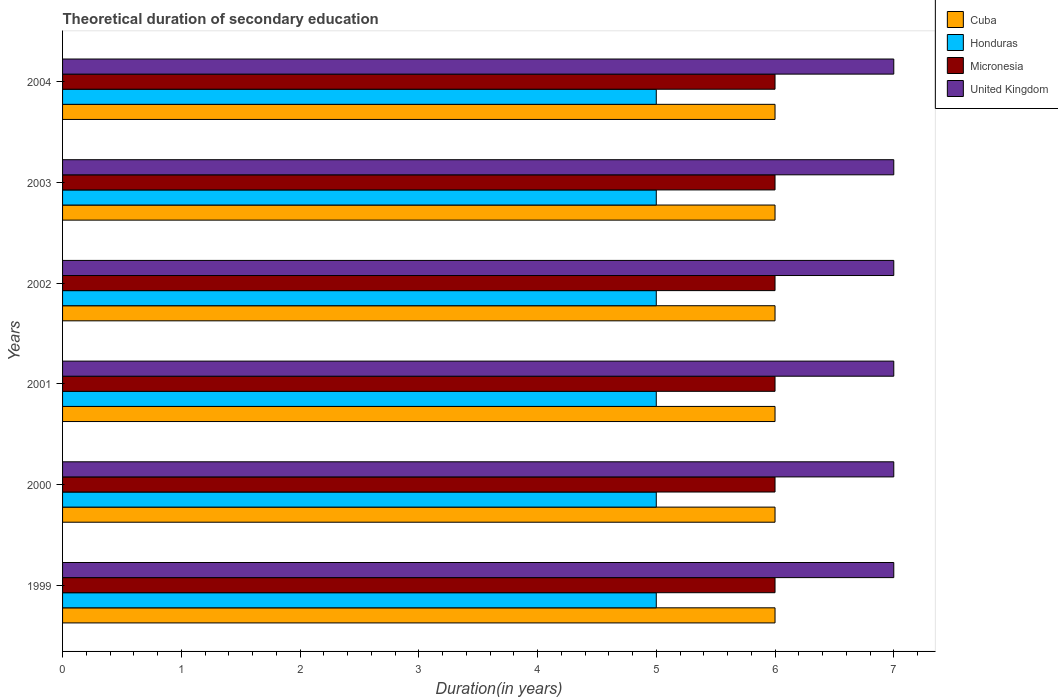How many different coloured bars are there?
Your response must be concise. 4. Are the number of bars per tick equal to the number of legend labels?
Your answer should be compact. Yes. Are the number of bars on each tick of the Y-axis equal?
Keep it short and to the point. Yes. How many bars are there on the 2nd tick from the top?
Offer a terse response. 4. How many bars are there on the 6th tick from the bottom?
Offer a terse response. 4. What is the total theoretical duration of secondary education in United Kingdom in 2004?
Ensure brevity in your answer.  7. Across all years, what is the maximum total theoretical duration of secondary education in Cuba?
Your response must be concise. 6. Across all years, what is the minimum total theoretical duration of secondary education in United Kingdom?
Make the answer very short. 7. In which year was the total theoretical duration of secondary education in Honduras maximum?
Provide a succinct answer. 1999. In which year was the total theoretical duration of secondary education in Cuba minimum?
Your response must be concise. 1999. What is the total total theoretical duration of secondary education in Honduras in the graph?
Keep it short and to the point. 30. What is the difference between the total theoretical duration of secondary education in United Kingdom in 2000 and the total theoretical duration of secondary education in Honduras in 2001?
Offer a very short reply. 2. In the year 1999, what is the difference between the total theoretical duration of secondary education in United Kingdom and total theoretical duration of secondary education in Honduras?
Keep it short and to the point. 2. What is the difference between the highest and the lowest total theoretical duration of secondary education in United Kingdom?
Make the answer very short. 0. In how many years, is the total theoretical duration of secondary education in Honduras greater than the average total theoretical duration of secondary education in Honduras taken over all years?
Offer a very short reply. 0. Is the sum of the total theoretical duration of secondary education in Cuba in 2001 and 2004 greater than the maximum total theoretical duration of secondary education in United Kingdom across all years?
Make the answer very short. Yes. Is it the case that in every year, the sum of the total theoretical duration of secondary education in Cuba and total theoretical duration of secondary education in Honduras is greater than the sum of total theoretical duration of secondary education in Micronesia and total theoretical duration of secondary education in United Kingdom?
Your response must be concise. Yes. What does the 1st bar from the top in 2002 represents?
Offer a terse response. United Kingdom. What does the 3rd bar from the bottom in 2002 represents?
Offer a very short reply. Micronesia. Are all the bars in the graph horizontal?
Provide a succinct answer. Yes. How many years are there in the graph?
Ensure brevity in your answer.  6. Are the values on the major ticks of X-axis written in scientific E-notation?
Your response must be concise. No. Does the graph contain any zero values?
Keep it short and to the point. No. Where does the legend appear in the graph?
Your answer should be compact. Top right. How many legend labels are there?
Ensure brevity in your answer.  4. How are the legend labels stacked?
Your response must be concise. Vertical. What is the title of the graph?
Your answer should be compact. Theoretical duration of secondary education. What is the label or title of the X-axis?
Provide a short and direct response. Duration(in years). What is the label or title of the Y-axis?
Provide a short and direct response. Years. What is the Duration(in years) in Cuba in 1999?
Ensure brevity in your answer.  6. What is the Duration(in years) of Honduras in 1999?
Make the answer very short. 5. What is the Duration(in years) in Micronesia in 1999?
Your response must be concise. 6. What is the Duration(in years) in United Kingdom in 1999?
Your response must be concise. 7. What is the Duration(in years) of Cuba in 2000?
Provide a succinct answer. 6. What is the Duration(in years) in Honduras in 2000?
Keep it short and to the point. 5. What is the Duration(in years) of Micronesia in 2000?
Offer a terse response. 6. What is the Duration(in years) of Cuba in 2001?
Provide a short and direct response. 6. What is the Duration(in years) of Cuba in 2002?
Your answer should be very brief. 6. What is the Duration(in years) of Honduras in 2002?
Keep it short and to the point. 5. What is the Duration(in years) in Micronesia in 2003?
Keep it short and to the point. 6. What is the Duration(in years) of Honduras in 2004?
Offer a terse response. 5. What is the Duration(in years) in Micronesia in 2004?
Make the answer very short. 6. What is the Duration(in years) in United Kingdom in 2004?
Provide a short and direct response. 7. Across all years, what is the maximum Duration(in years) of Honduras?
Ensure brevity in your answer.  5. Across all years, what is the minimum Duration(in years) in United Kingdom?
Provide a succinct answer. 7. What is the total Duration(in years) in Micronesia in the graph?
Provide a succinct answer. 36. What is the difference between the Duration(in years) of Cuba in 1999 and that in 2000?
Ensure brevity in your answer.  0. What is the difference between the Duration(in years) in Honduras in 1999 and that in 2000?
Give a very brief answer. 0. What is the difference between the Duration(in years) of Micronesia in 1999 and that in 2000?
Your response must be concise. 0. What is the difference between the Duration(in years) of United Kingdom in 1999 and that in 2001?
Provide a succinct answer. 0. What is the difference between the Duration(in years) of Cuba in 1999 and that in 2002?
Make the answer very short. 0. What is the difference between the Duration(in years) of Honduras in 1999 and that in 2002?
Make the answer very short. 0. What is the difference between the Duration(in years) in United Kingdom in 1999 and that in 2002?
Make the answer very short. 0. What is the difference between the Duration(in years) of Cuba in 1999 and that in 2003?
Your answer should be very brief. 0. What is the difference between the Duration(in years) in Honduras in 1999 and that in 2004?
Your answer should be very brief. 0. What is the difference between the Duration(in years) of Micronesia in 1999 and that in 2004?
Your answer should be compact. 0. What is the difference between the Duration(in years) of Honduras in 2000 and that in 2002?
Offer a terse response. 0. What is the difference between the Duration(in years) of United Kingdom in 2000 and that in 2002?
Your response must be concise. 0. What is the difference between the Duration(in years) in Cuba in 2000 and that in 2003?
Provide a succinct answer. 0. What is the difference between the Duration(in years) of United Kingdom in 2000 and that in 2003?
Provide a short and direct response. 0. What is the difference between the Duration(in years) in Cuba in 2001 and that in 2002?
Offer a very short reply. 0. What is the difference between the Duration(in years) in United Kingdom in 2001 and that in 2002?
Offer a terse response. 0. What is the difference between the Duration(in years) of Cuba in 2001 and that in 2003?
Provide a short and direct response. 0. What is the difference between the Duration(in years) of Honduras in 2001 and that in 2003?
Keep it short and to the point. 0. What is the difference between the Duration(in years) in Cuba in 2002 and that in 2003?
Offer a very short reply. 0. What is the difference between the Duration(in years) of Honduras in 2002 and that in 2003?
Ensure brevity in your answer.  0. What is the difference between the Duration(in years) of Micronesia in 2002 and that in 2003?
Offer a very short reply. 0. What is the difference between the Duration(in years) in United Kingdom in 2002 and that in 2003?
Ensure brevity in your answer.  0. What is the difference between the Duration(in years) in Micronesia in 2003 and that in 2004?
Provide a short and direct response. 0. What is the difference between the Duration(in years) of United Kingdom in 2003 and that in 2004?
Provide a short and direct response. 0. What is the difference between the Duration(in years) of Honduras in 1999 and the Duration(in years) of United Kingdom in 2000?
Your answer should be compact. -2. What is the difference between the Duration(in years) of Honduras in 1999 and the Duration(in years) of Micronesia in 2001?
Offer a terse response. -1. What is the difference between the Duration(in years) in Honduras in 1999 and the Duration(in years) in United Kingdom in 2001?
Ensure brevity in your answer.  -2. What is the difference between the Duration(in years) in Cuba in 1999 and the Duration(in years) in Honduras in 2002?
Give a very brief answer. 1. What is the difference between the Duration(in years) of Cuba in 1999 and the Duration(in years) of United Kingdom in 2002?
Your answer should be very brief. -1. What is the difference between the Duration(in years) in Honduras in 1999 and the Duration(in years) in Micronesia in 2002?
Your response must be concise. -1. What is the difference between the Duration(in years) in Cuba in 1999 and the Duration(in years) in Micronesia in 2003?
Give a very brief answer. 0. What is the difference between the Duration(in years) of Cuba in 1999 and the Duration(in years) of United Kingdom in 2003?
Your answer should be compact. -1. What is the difference between the Duration(in years) of Honduras in 1999 and the Duration(in years) of Micronesia in 2003?
Provide a succinct answer. -1. What is the difference between the Duration(in years) in Micronesia in 1999 and the Duration(in years) in United Kingdom in 2003?
Offer a very short reply. -1. What is the difference between the Duration(in years) of Cuba in 1999 and the Duration(in years) of Honduras in 2004?
Ensure brevity in your answer.  1. What is the difference between the Duration(in years) of Honduras in 1999 and the Duration(in years) of United Kingdom in 2004?
Offer a terse response. -2. What is the difference between the Duration(in years) of Micronesia in 1999 and the Duration(in years) of United Kingdom in 2004?
Make the answer very short. -1. What is the difference between the Duration(in years) of Cuba in 2000 and the Duration(in years) of United Kingdom in 2001?
Your answer should be compact. -1. What is the difference between the Duration(in years) of Micronesia in 2000 and the Duration(in years) of United Kingdom in 2001?
Your answer should be compact. -1. What is the difference between the Duration(in years) in Cuba in 2000 and the Duration(in years) in Honduras in 2002?
Provide a short and direct response. 1. What is the difference between the Duration(in years) in Honduras in 2000 and the Duration(in years) in Micronesia in 2002?
Offer a very short reply. -1. What is the difference between the Duration(in years) of Honduras in 2000 and the Duration(in years) of United Kingdom in 2002?
Keep it short and to the point. -2. What is the difference between the Duration(in years) in Micronesia in 2000 and the Duration(in years) in United Kingdom in 2002?
Make the answer very short. -1. What is the difference between the Duration(in years) in Honduras in 2000 and the Duration(in years) in Micronesia in 2003?
Offer a terse response. -1. What is the difference between the Duration(in years) of Micronesia in 2000 and the Duration(in years) of United Kingdom in 2003?
Give a very brief answer. -1. What is the difference between the Duration(in years) of Cuba in 2000 and the Duration(in years) of Micronesia in 2004?
Give a very brief answer. 0. What is the difference between the Duration(in years) of Cuba in 2000 and the Duration(in years) of United Kingdom in 2004?
Provide a succinct answer. -1. What is the difference between the Duration(in years) in Honduras in 2000 and the Duration(in years) in Micronesia in 2004?
Your answer should be very brief. -1. What is the difference between the Duration(in years) in Cuba in 2001 and the Duration(in years) in Honduras in 2002?
Your answer should be compact. 1. What is the difference between the Duration(in years) in Cuba in 2001 and the Duration(in years) in United Kingdom in 2002?
Keep it short and to the point. -1. What is the difference between the Duration(in years) of Honduras in 2001 and the Duration(in years) of Micronesia in 2002?
Offer a terse response. -1. What is the difference between the Duration(in years) of Micronesia in 2001 and the Duration(in years) of United Kingdom in 2002?
Offer a terse response. -1. What is the difference between the Duration(in years) of Cuba in 2001 and the Duration(in years) of Honduras in 2003?
Provide a short and direct response. 1. What is the difference between the Duration(in years) of Cuba in 2001 and the Duration(in years) of Micronesia in 2003?
Give a very brief answer. 0. What is the difference between the Duration(in years) of Cuba in 2001 and the Duration(in years) of United Kingdom in 2003?
Ensure brevity in your answer.  -1. What is the difference between the Duration(in years) in Cuba in 2001 and the Duration(in years) in Micronesia in 2004?
Ensure brevity in your answer.  0. What is the difference between the Duration(in years) of Cuba in 2001 and the Duration(in years) of United Kingdom in 2004?
Offer a terse response. -1. What is the difference between the Duration(in years) of Micronesia in 2001 and the Duration(in years) of United Kingdom in 2004?
Offer a terse response. -1. What is the difference between the Duration(in years) of Cuba in 2002 and the Duration(in years) of Honduras in 2003?
Ensure brevity in your answer.  1. What is the difference between the Duration(in years) in Honduras in 2002 and the Duration(in years) in United Kingdom in 2003?
Your answer should be compact. -2. What is the difference between the Duration(in years) in Cuba in 2002 and the Duration(in years) in United Kingdom in 2004?
Keep it short and to the point. -1. What is the difference between the Duration(in years) in Honduras in 2002 and the Duration(in years) in Micronesia in 2004?
Your response must be concise. -1. What is the difference between the Duration(in years) in Micronesia in 2002 and the Duration(in years) in United Kingdom in 2004?
Your response must be concise. -1. What is the difference between the Duration(in years) in Cuba in 2003 and the Duration(in years) in Micronesia in 2004?
Offer a very short reply. 0. What is the difference between the Duration(in years) in Honduras in 2003 and the Duration(in years) in Micronesia in 2004?
Give a very brief answer. -1. What is the difference between the Duration(in years) in Micronesia in 2003 and the Duration(in years) in United Kingdom in 2004?
Offer a very short reply. -1. What is the average Duration(in years) in Cuba per year?
Your response must be concise. 6. In the year 1999, what is the difference between the Duration(in years) in Cuba and Duration(in years) in Micronesia?
Offer a terse response. 0. In the year 1999, what is the difference between the Duration(in years) of Honduras and Duration(in years) of United Kingdom?
Offer a very short reply. -2. In the year 2000, what is the difference between the Duration(in years) in Cuba and Duration(in years) in Micronesia?
Ensure brevity in your answer.  0. In the year 2000, what is the difference between the Duration(in years) of Honduras and Duration(in years) of United Kingdom?
Your answer should be compact. -2. In the year 2000, what is the difference between the Duration(in years) of Micronesia and Duration(in years) of United Kingdom?
Your answer should be very brief. -1. In the year 2001, what is the difference between the Duration(in years) of Cuba and Duration(in years) of Honduras?
Provide a short and direct response. 1. In the year 2001, what is the difference between the Duration(in years) of Cuba and Duration(in years) of Micronesia?
Provide a short and direct response. 0. In the year 2001, what is the difference between the Duration(in years) of Micronesia and Duration(in years) of United Kingdom?
Make the answer very short. -1. In the year 2002, what is the difference between the Duration(in years) of Honduras and Duration(in years) of United Kingdom?
Offer a very short reply. -2. In the year 2003, what is the difference between the Duration(in years) of Cuba and Duration(in years) of Honduras?
Provide a short and direct response. 1. In the year 2003, what is the difference between the Duration(in years) in Cuba and Duration(in years) in United Kingdom?
Offer a terse response. -1. In the year 2003, what is the difference between the Duration(in years) in Micronesia and Duration(in years) in United Kingdom?
Make the answer very short. -1. In the year 2004, what is the difference between the Duration(in years) in Cuba and Duration(in years) in Micronesia?
Offer a very short reply. 0. In the year 2004, what is the difference between the Duration(in years) of Cuba and Duration(in years) of United Kingdom?
Ensure brevity in your answer.  -1. In the year 2004, what is the difference between the Duration(in years) in Honduras and Duration(in years) in Micronesia?
Provide a short and direct response. -1. In the year 2004, what is the difference between the Duration(in years) of Honduras and Duration(in years) of United Kingdom?
Your response must be concise. -2. In the year 2004, what is the difference between the Duration(in years) in Micronesia and Duration(in years) in United Kingdom?
Keep it short and to the point. -1. What is the ratio of the Duration(in years) of Cuba in 1999 to that in 2000?
Offer a terse response. 1. What is the ratio of the Duration(in years) in Honduras in 1999 to that in 2000?
Your answer should be very brief. 1. What is the ratio of the Duration(in years) in Micronesia in 1999 to that in 2000?
Provide a short and direct response. 1. What is the ratio of the Duration(in years) of Cuba in 1999 to that in 2001?
Your answer should be compact. 1. What is the ratio of the Duration(in years) in Micronesia in 1999 to that in 2001?
Keep it short and to the point. 1. What is the ratio of the Duration(in years) of United Kingdom in 1999 to that in 2001?
Keep it short and to the point. 1. What is the ratio of the Duration(in years) in Honduras in 1999 to that in 2002?
Your response must be concise. 1. What is the ratio of the Duration(in years) in Micronesia in 1999 to that in 2002?
Offer a very short reply. 1. What is the ratio of the Duration(in years) in United Kingdom in 1999 to that in 2002?
Your answer should be compact. 1. What is the ratio of the Duration(in years) in Honduras in 1999 to that in 2004?
Offer a terse response. 1. What is the ratio of the Duration(in years) of Micronesia in 1999 to that in 2004?
Your response must be concise. 1. What is the ratio of the Duration(in years) in United Kingdom in 1999 to that in 2004?
Provide a succinct answer. 1. What is the ratio of the Duration(in years) of Honduras in 2000 to that in 2001?
Your response must be concise. 1. What is the ratio of the Duration(in years) of Micronesia in 2000 to that in 2001?
Ensure brevity in your answer.  1. What is the ratio of the Duration(in years) of Cuba in 2000 to that in 2002?
Offer a terse response. 1. What is the ratio of the Duration(in years) in Micronesia in 2000 to that in 2002?
Make the answer very short. 1. What is the ratio of the Duration(in years) of United Kingdom in 2000 to that in 2003?
Make the answer very short. 1. What is the ratio of the Duration(in years) of Cuba in 2000 to that in 2004?
Give a very brief answer. 1. What is the ratio of the Duration(in years) of Honduras in 2000 to that in 2004?
Ensure brevity in your answer.  1. What is the ratio of the Duration(in years) of Cuba in 2001 to that in 2002?
Make the answer very short. 1. What is the ratio of the Duration(in years) of Honduras in 2001 to that in 2002?
Ensure brevity in your answer.  1. What is the ratio of the Duration(in years) of United Kingdom in 2001 to that in 2002?
Provide a succinct answer. 1. What is the ratio of the Duration(in years) in United Kingdom in 2001 to that in 2003?
Ensure brevity in your answer.  1. What is the ratio of the Duration(in years) in Cuba in 2001 to that in 2004?
Ensure brevity in your answer.  1. What is the ratio of the Duration(in years) in Micronesia in 2001 to that in 2004?
Give a very brief answer. 1. What is the ratio of the Duration(in years) in United Kingdom in 2001 to that in 2004?
Provide a short and direct response. 1. What is the ratio of the Duration(in years) of Cuba in 2002 to that in 2003?
Provide a short and direct response. 1. What is the ratio of the Duration(in years) in Honduras in 2002 to that in 2003?
Provide a succinct answer. 1. What is the ratio of the Duration(in years) of United Kingdom in 2002 to that in 2003?
Provide a short and direct response. 1. What is the ratio of the Duration(in years) in Honduras in 2002 to that in 2004?
Provide a succinct answer. 1. What is the ratio of the Duration(in years) in Micronesia in 2002 to that in 2004?
Offer a very short reply. 1. What is the ratio of the Duration(in years) in United Kingdom in 2002 to that in 2004?
Offer a very short reply. 1. What is the ratio of the Duration(in years) in Cuba in 2003 to that in 2004?
Your answer should be very brief. 1. What is the ratio of the Duration(in years) in Micronesia in 2003 to that in 2004?
Give a very brief answer. 1. What is the ratio of the Duration(in years) in United Kingdom in 2003 to that in 2004?
Offer a terse response. 1. What is the difference between the highest and the second highest Duration(in years) in Micronesia?
Your response must be concise. 0. What is the difference between the highest and the lowest Duration(in years) of Cuba?
Ensure brevity in your answer.  0. What is the difference between the highest and the lowest Duration(in years) of Micronesia?
Keep it short and to the point. 0. 